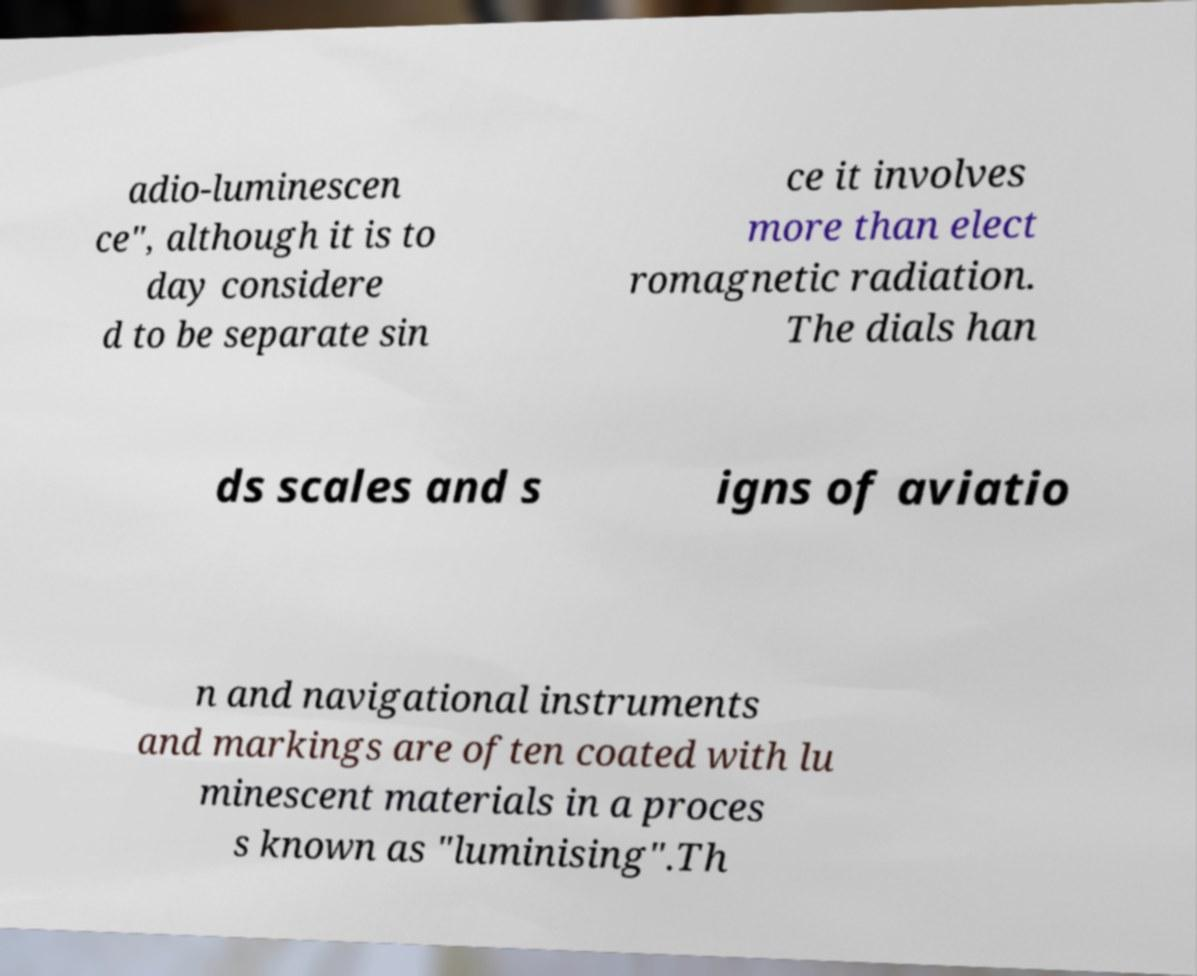For documentation purposes, I need the text within this image transcribed. Could you provide that? adio-luminescen ce", although it is to day considere d to be separate sin ce it involves more than elect romagnetic radiation. The dials han ds scales and s igns of aviatio n and navigational instruments and markings are often coated with lu minescent materials in a proces s known as "luminising".Th 